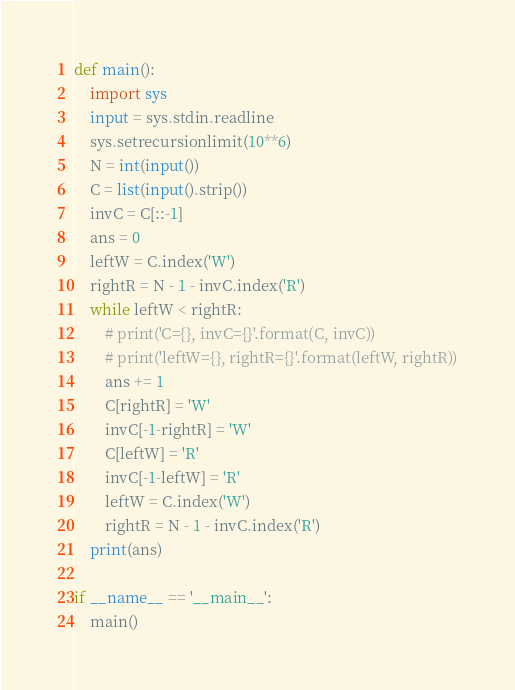Convert code to text. <code><loc_0><loc_0><loc_500><loc_500><_Python_>def main():
    import sys
    input = sys.stdin.readline
    sys.setrecursionlimit(10**6)
    N = int(input())
    C = list(input().strip())
    invC = C[::-1]
    ans = 0
    leftW = C.index('W')
    rightR = N - 1 - invC.index('R')
    while leftW < rightR:
        # print('C={}, invC={}'.format(C, invC))
        # print('leftW={}, rightR={}'.format(leftW, rightR))
        ans += 1
        C[rightR] = 'W'
        invC[-1-rightR] = 'W'
        C[leftW] = 'R'
        invC[-1-leftW] = 'R'
        leftW = C.index('W')
        rightR = N - 1 - invC.index('R')
    print(ans)

if __name__ == '__main__':
    main()</code> 